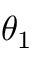Convert formula to latex. <formula><loc_0><loc_0><loc_500><loc_500>\theta _ { 1 }</formula> 